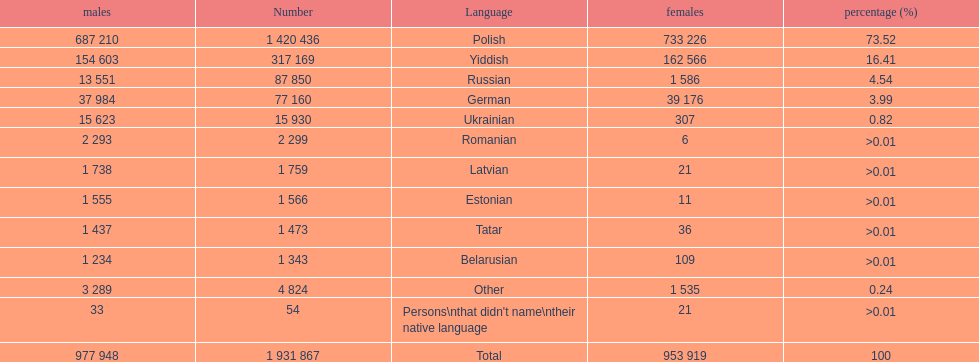01, which one was at the top? Romanian. 